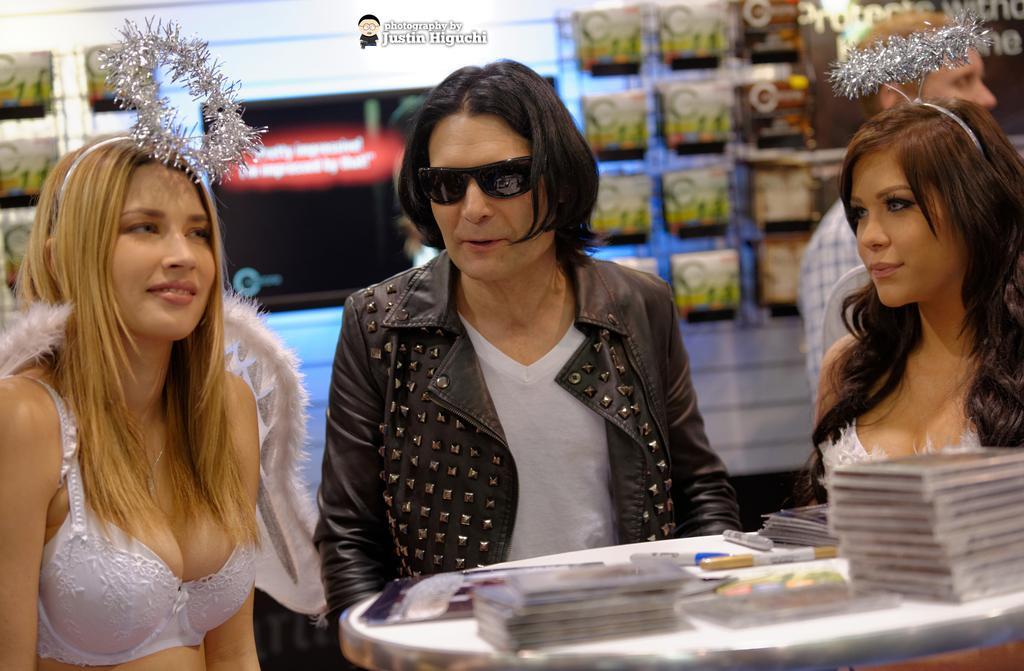In one or two sentences, can you explain what this image depicts? In the center of the image we can see three people standing, before them there is a table and we can see books, pens and some things placed on the table. In the background there is a board. 